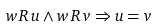<formula> <loc_0><loc_0><loc_500><loc_500>w \, R \, u \land w \, R \, v \Rightarrow u = v</formula> 